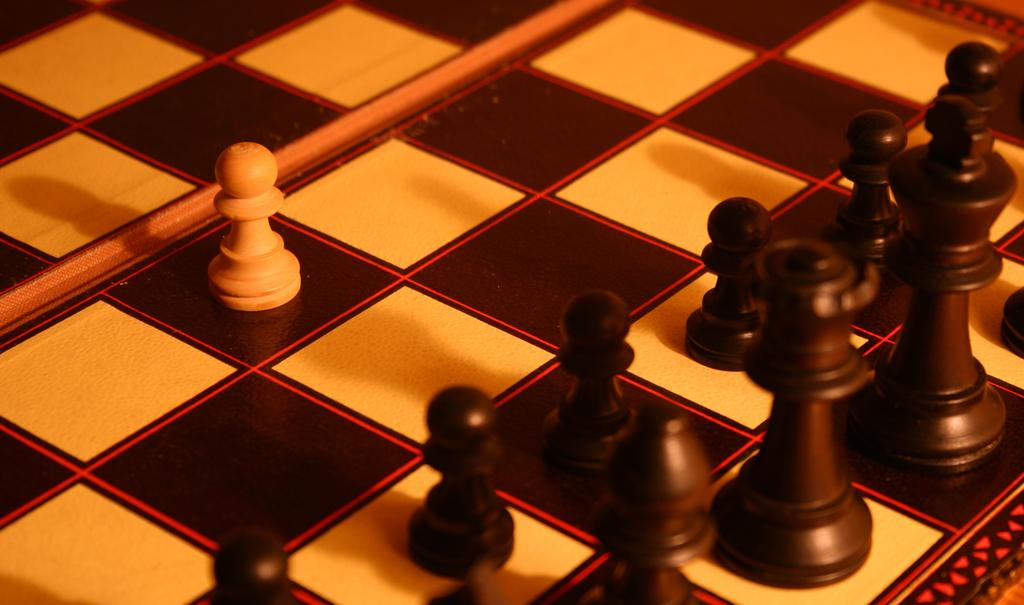What is the main object in the image? There is a chess board in the image. What is placed on the chess board? There are chess pieces on the chess board. What type of zephyr can be seen blowing through the chess pieces in the image? There is no zephyr present in the image, and therefore no such activity can be observed. 